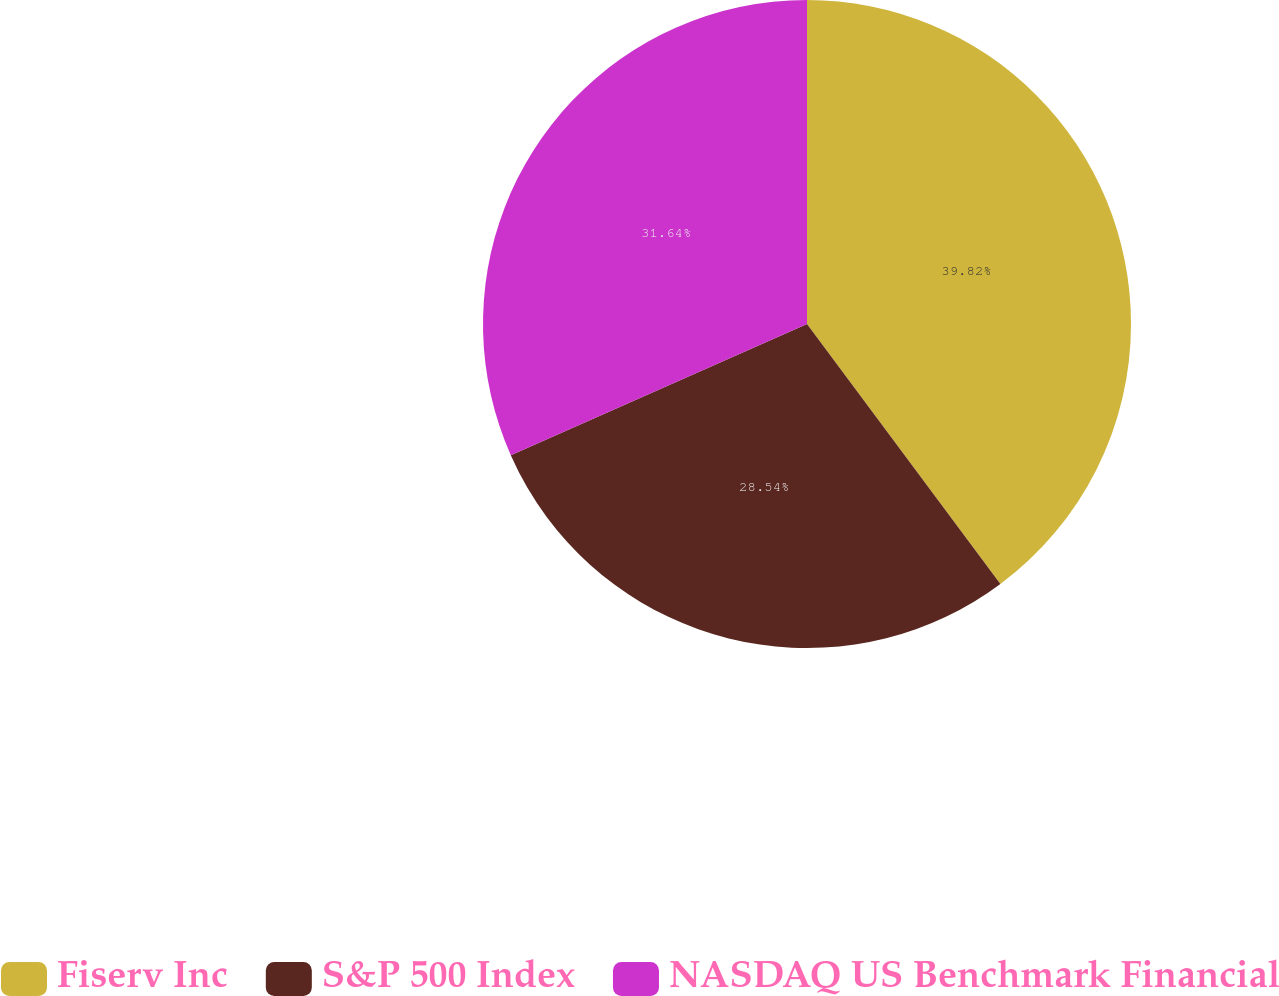Convert chart to OTSL. <chart><loc_0><loc_0><loc_500><loc_500><pie_chart><fcel>Fiserv Inc<fcel>S&P 500 Index<fcel>NASDAQ US Benchmark Financial<nl><fcel>39.82%<fcel>28.54%<fcel>31.64%<nl></chart> 